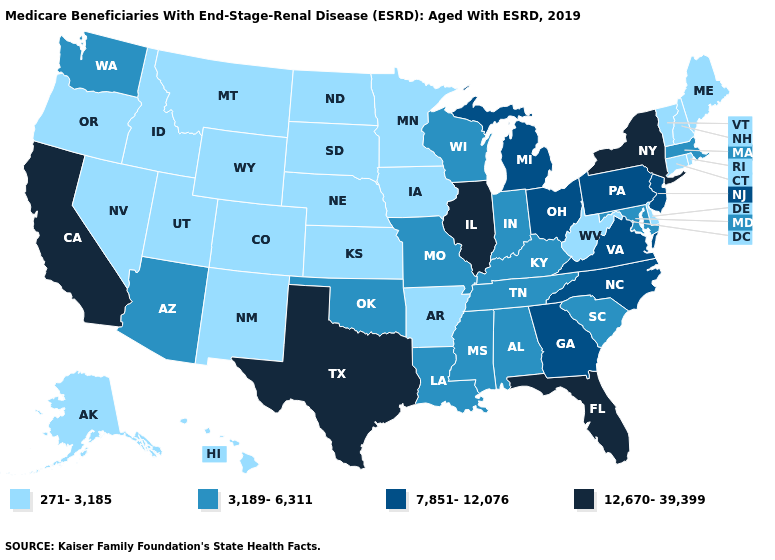Name the states that have a value in the range 271-3,185?
Give a very brief answer. Alaska, Arkansas, Colorado, Connecticut, Delaware, Hawaii, Idaho, Iowa, Kansas, Maine, Minnesota, Montana, Nebraska, Nevada, New Hampshire, New Mexico, North Dakota, Oregon, Rhode Island, South Dakota, Utah, Vermont, West Virginia, Wyoming. Does Oregon have the lowest value in the West?
Be succinct. Yes. Is the legend a continuous bar?
Keep it brief. No. Does the first symbol in the legend represent the smallest category?
Write a very short answer. Yes. Among the states that border Wisconsin , does Iowa have the lowest value?
Give a very brief answer. Yes. What is the value of Missouri?
Quick response, please. 3,189-6,311. Which states have the lowest value in the USA?
Give a very brief answer. Alaska, Arkansas, Colorado, Connecticut, Delaware, Hawaii, Idaho, Iowa, Kansas, Maine, Minnesota, Montana, Nebraska, Nevada, New Hampshire, New Mexico, North Dakota, Oregon, Rhode Island, South Dakota, Utah, Vermont, West Virginia, Wyoming. Is the legend a continuous bar?
Short answer required. No. What is the highest value in states that border Washington?
Give a very brief answer. 271-3,185. Name the states that have a value in the range 271-3,185?
Answer briefly. Alaska, Arkansas, Colorado, Connecticut, Delaware, Hawaii, Idaho, Iowa, Kansas, Maine, Minnesota, Montana, Nebraska, Nevada, New Hampshire, New Mexico, North Dakota, Oregon, Rhode Island, South Dakota, Utah, Vermont, West Virginia, Wyoming. Among the states that border Michigan , which have the lowest value?
Write a very short answer. Indiana, Wisconsin. What is the lowest value in states that border Minnesota?
Write a very short answer. 271-3,185. What is the highest value in the USA?
Answer briefly. 12,670-39,399. Does South Dakota have the lowest value in the MidWest?
Short answer required. Yes. Which states have the lowest value in the USA?
Give a very brief answer. Alaska, Arkansas, Colorado, Connecticut, Delaware, Hawaii, Idaho, Iowa, Kansas, Maine, Minnesota, Montana, Nebraska, Nevada, New Hampshire, New Mexico, North Dakota, Oregon, Rhode Island, South Dakota, Utah, Vermont, West Virginia, Wyoming. 